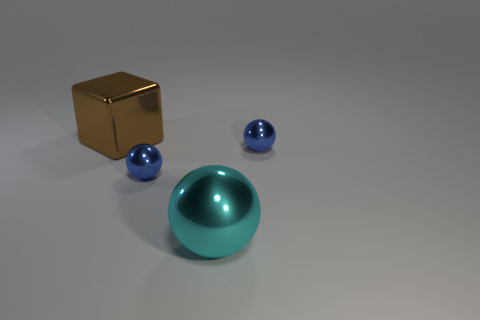Subtract all purple cylinders. How many blue balls are left? 2 Subtract all tiny metal balls. How many balls are left? 1 Add 4 small metal balls. How many objects exist? 8 Subtract all cyan balls. How many balls are left? 2 Subtract all spheres. How many objects are left? 1 Subtract 2 spheres. How many spheres are left? 1 Subtract all gray cubes. Subtract all yellow cylinders. How many cubes are left? 1 Subtract all brown blocks. Subtract all blue metallic spheres. How many objects are left? 1 Add 2 large brown things. How many large brown things are left? 3 Add 2 large metallic things. How many large metallic things exist? 4 